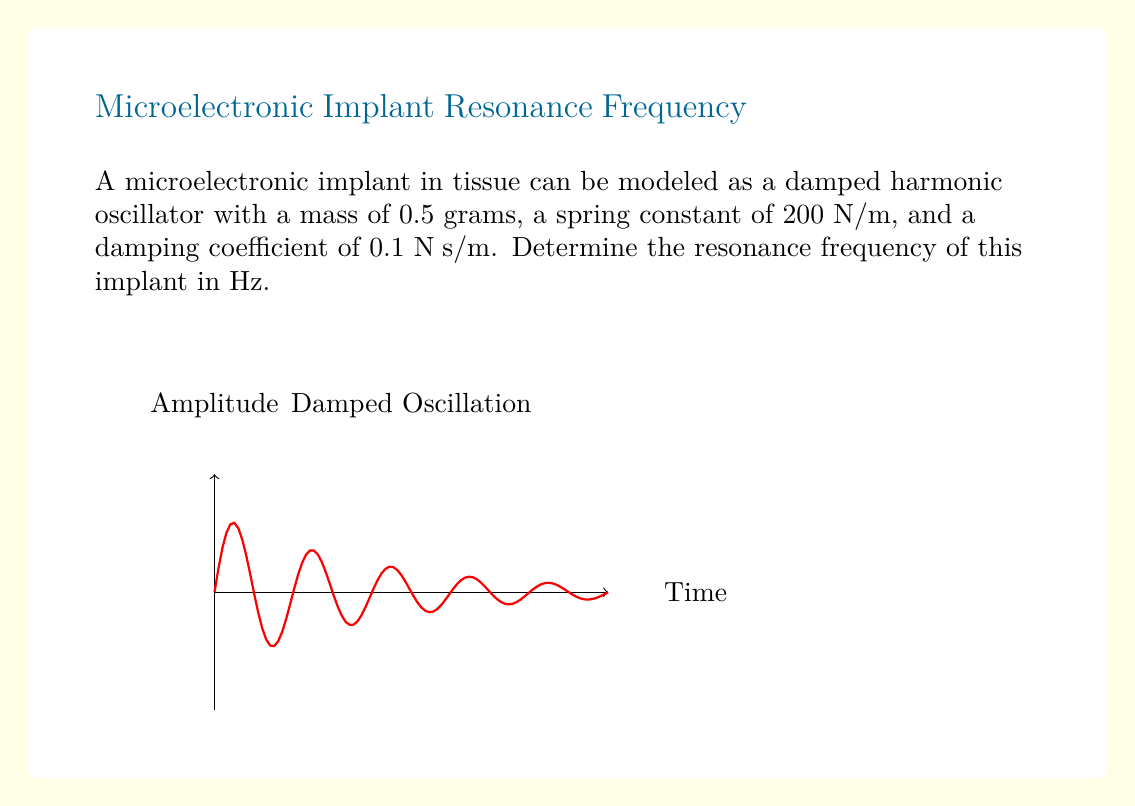Can you answer this question? To determine the resonance frequency, we follow these steps:

1) The general form of a second-order linear differential equation for a damped harmonic oscillator is:

   $$m\frac{d^2x}{dt^2} + b\frac{dx}{dt} + kx = 0$$

   where $m$ is mass, $b$ is the damping coefficient, and $k$ is the spring constant.

2) The resonance frequency for a damped system is given by:

   $$\omega_0 = \sqrt{\frac{k}{m} - \frac{b^2}{4m^2}}$$

3) Substituting the given values:
   $m = 0.5 \times 10^{-3}$ kg
   $k = 200$ N/m
   $b = 0.1$ N⋅s/m

4) Calculate:
   $$\omega_0 = \sqrt{\frac{200}{0.5 \times 10^{-3}} - \frac{0.1^2}{4(0.5 \times 10^{-3})^2}}$$

5) Simplify:
   $$\omega_0 = \sqrt{400,000 - 10,000} = \sqrt{390,000} \approx 624.5 \text{ rad/s}$$

6) Convert from angular frequency (rad/s) to frequency (Hz):
   $$f = \frac{\omega_0}{2\pi} \approx \frac{624.5}{2\pi} \approx 99.4 \text{ Hz}$$
Answer: 99.4 Hz 